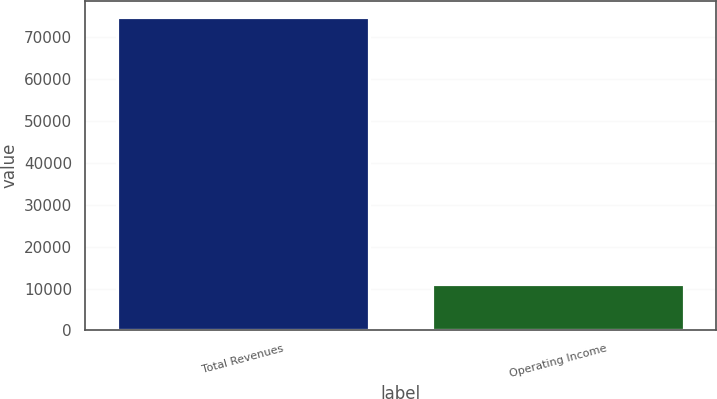Convert chart to OTSL. <chart><loc_0><loc_0><loc_500><loc_500><bar_chart><fcel>Total Revenues<fcel>Operating Income<nl><fcel>74957<fcel>11175<nl></chart> 